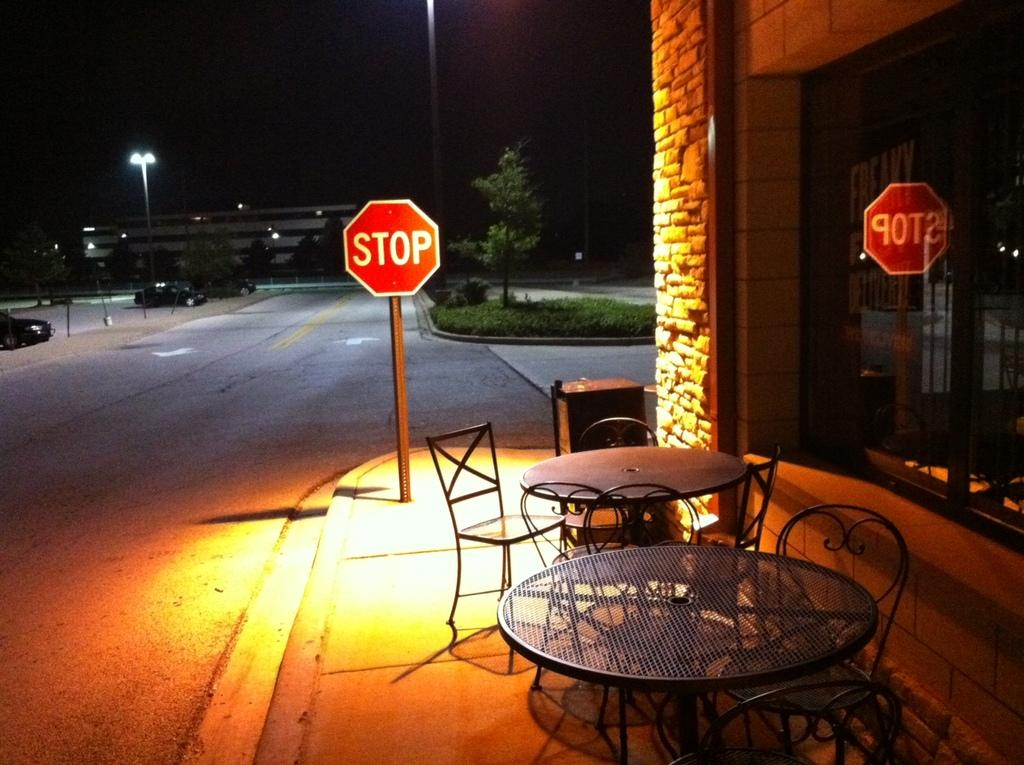What can be seen in the sky in the image? The sky is visible in the image. What type of lighting fixture is present in the image? There is a street light in the image. What type of structure is in the image? There is a building in the image. What type of signage is present in the image? A stop board is present in the image. What type of outdoor space is visible in the image? There is a patio in the image. What type of furniture is present in the image? A table and chairs are visible in the image. What type of vehicle is present in the image? There is a car in the image. What effect does the mother have on the car in the image? There is no mother present in the image, so it is not possible to determine any effect on the car. 